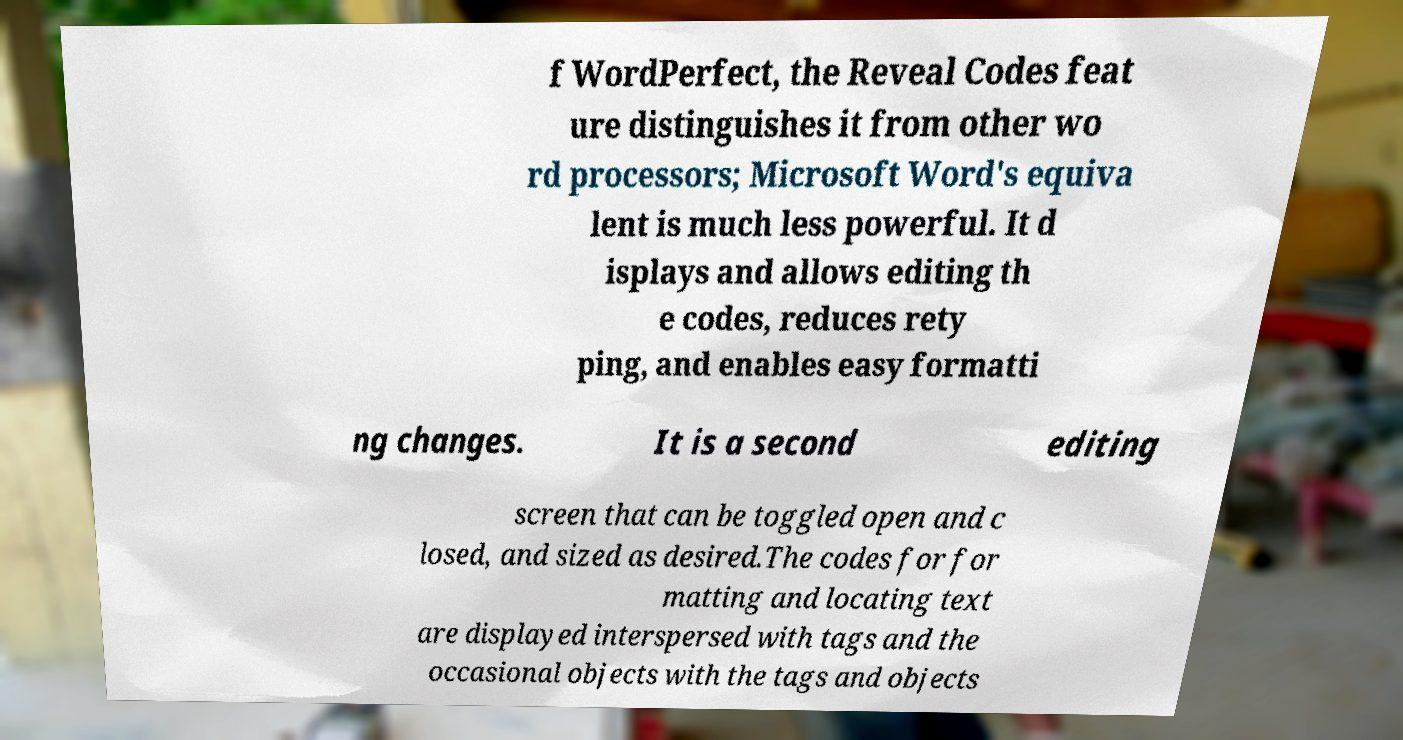Can you accurately transcribe the text from the provided image for me? f WordPerfect, the Reveal Codes feat ure distinguishes it from other wo rd processors; Microsoft Word's equiva lent is much less powerful. It d isplays and allows editing th e codes, reduces rety ping, and enables easy formatti ng changes. It is a second editing screen that can be toggled open and c losed, and sized as desired.The codes for for matting and locating text are displayed interspersed with tags and the occasional objects with the tags and objects 